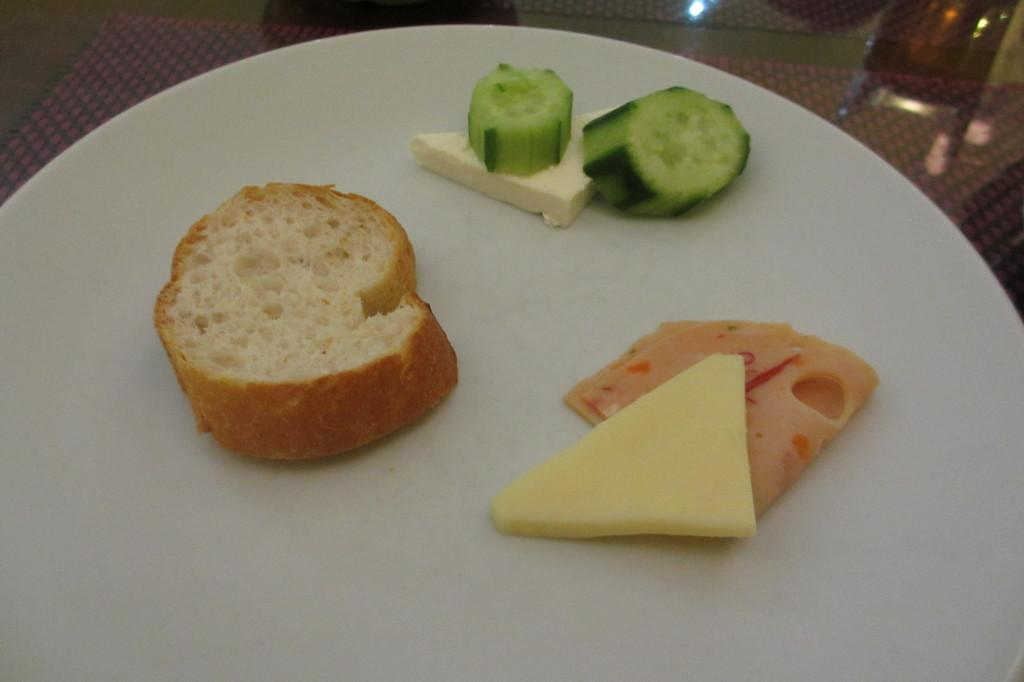What type of food can be seen in the image? There is a bread slice, cheese, and cucumber slices in the image. How are these food items arranged in the image? These items are served on a plate. What type of army discussion can be seen taking place in the image? There is no army discussion or any people present in the image; it only features food items served on a plate. 